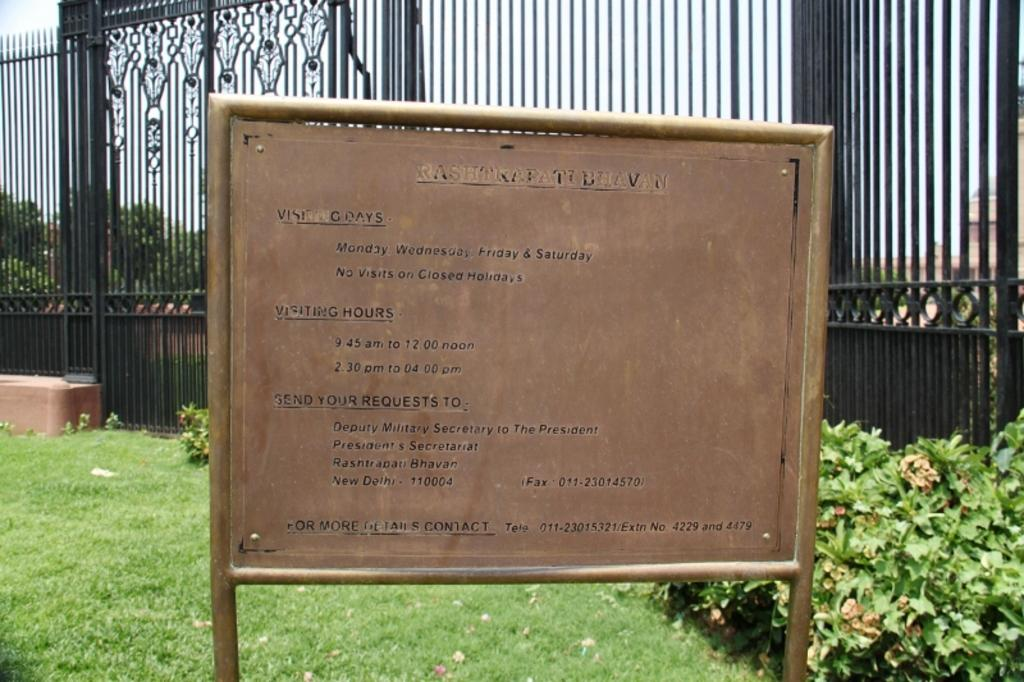What is on the board that is visible in the image? There is something written on the board in the image. What can be seen in the background of the image? In the background of the image, there is a fence, plants, grass, trees, and the sky. Can you describe the natural elements visible in the image? The natural elements visible in the image include grass, plants, and trees. How many frogs can be seen jumping in the image? There are no frogs visible in the image. What type of drop is falling from the sky in the image? There is no drop falling from the sky in the image. 